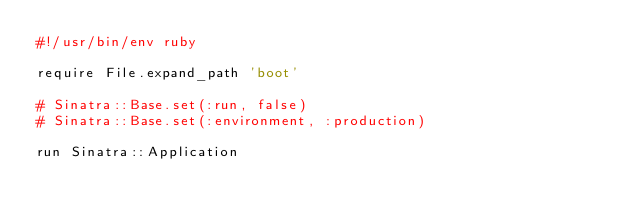<code> <loc_0><loc_0><loc_500><loc_500><_Ruby_>#!/usr/bin/env ruby

require File.expand_path 'boot'

# Sinatra::Base.set(:run, false)
# Sinatra::Base.set(:environment, :production)

run Sinatra::Application</code> 